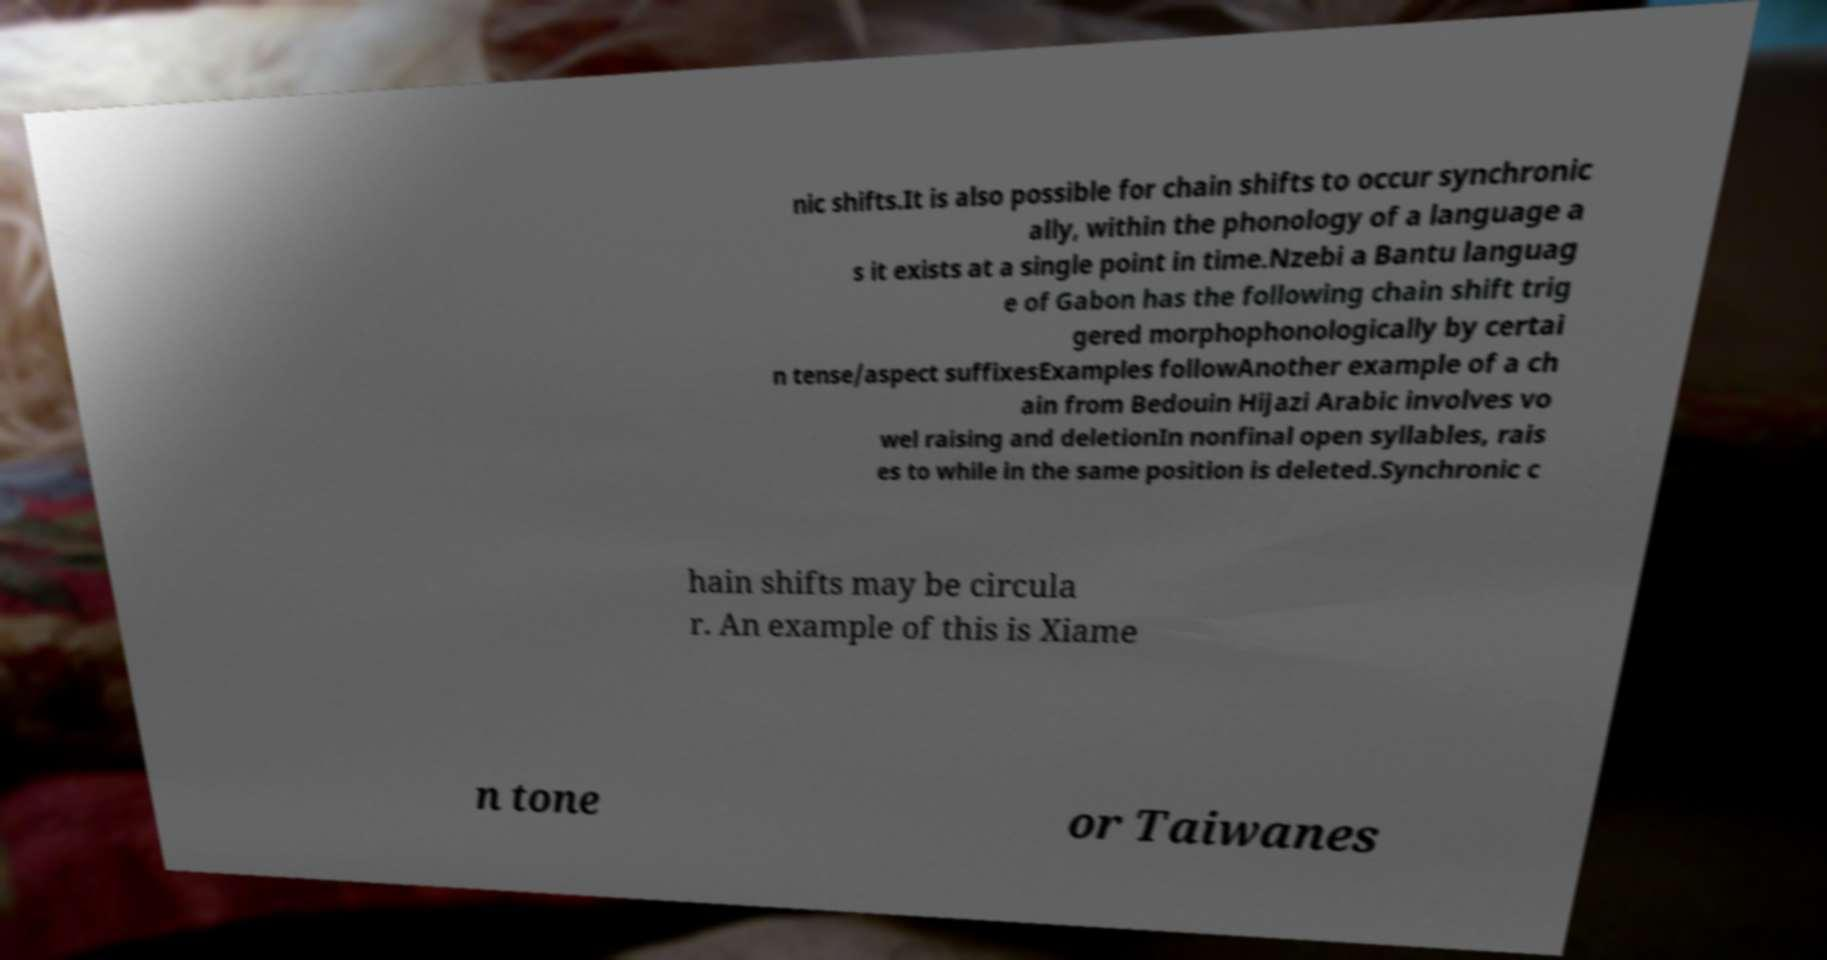Could you extract and type out the text from this image? nic shifts.It is also possible for chain shifts to occur synchronic ally, within the phonology of a language a s it exists at a single point in time.Nzebi a Bantu languag e of Gabon has the following chain shift trig gered morphophonologically by certai n tense/aspect suffixesExamples followAnother example of a ch ain from Bedouin Hijazi Arabic involves vo wel raising and deletionIn nonfinal open syllables, rais es to while in the same position is deleted.Synchronic c hain shifts may be circula r. An example of this is Xiame n tone or Taiwanes 